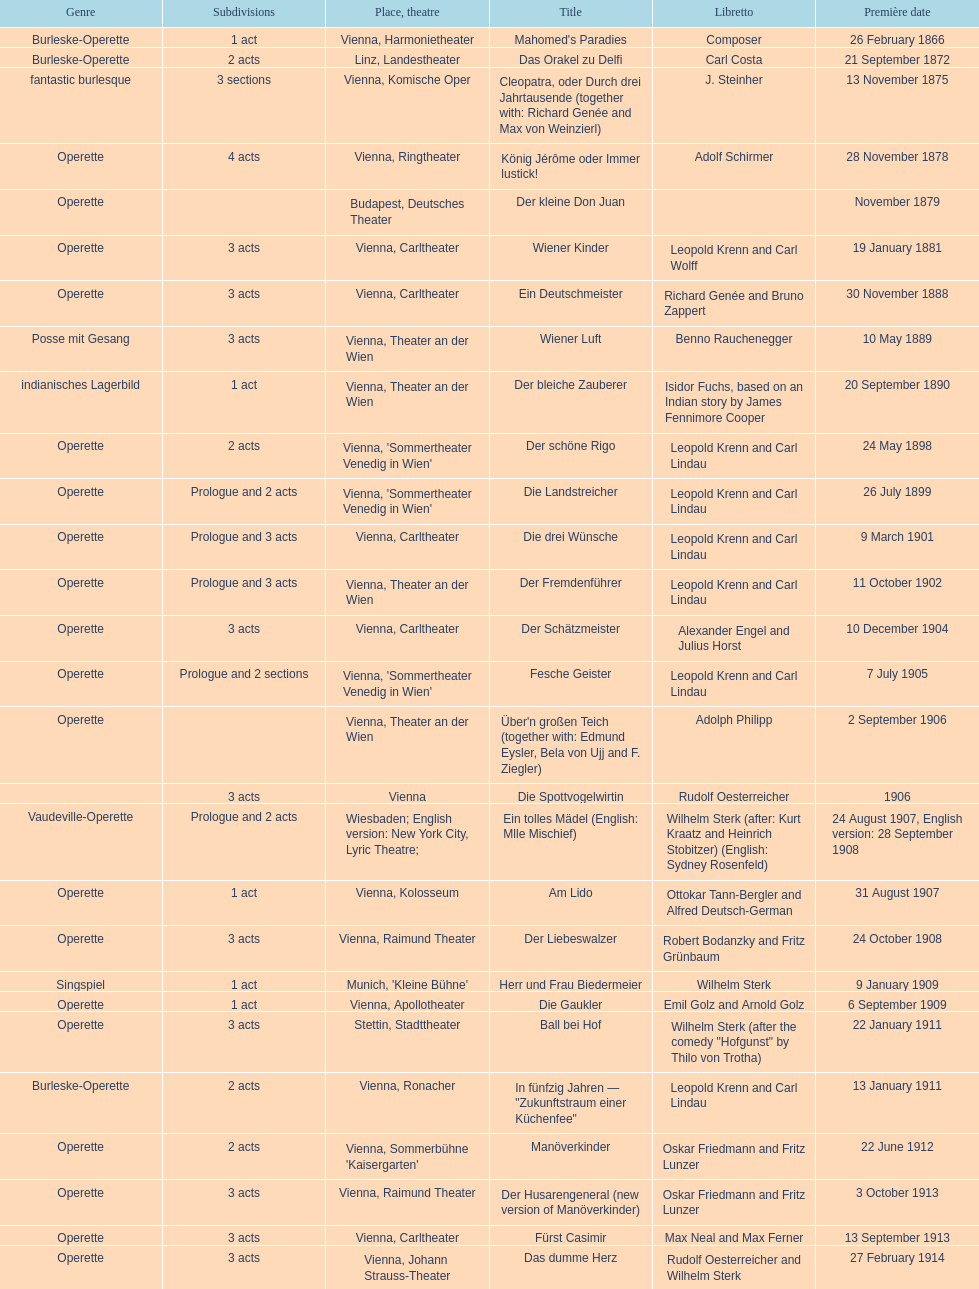What is the latest year for all the dates? 1958. 